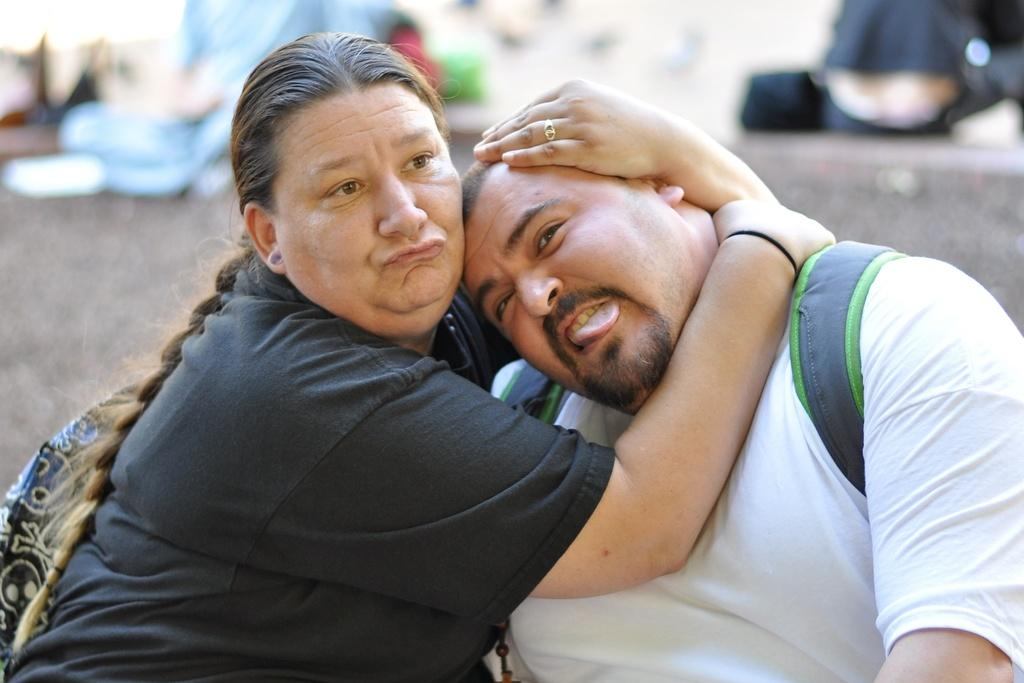How many people are present in the image? There is a man and a woman in the image. What are the man and woman doing in the image? The man and woman are sitting. Can you describe an object that might be present in the image? There is an object that might be a bag in the image. How would you describe the background of the image? The background of the image is blurry. How many clams can be seen in the image? There are no clams present in the image. What type of person is sitting next to the crib in the image? There is no crib or person sitting next to it in the image. 